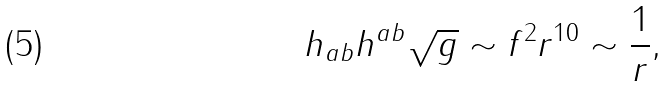Convert formula to latex. <formula><loc_0><loc_0><loc_500><loc_500>h _ { a b } h ^ { a b } \sqrt { g } \sim f ^ { 2 } r ^ { 1 0 } \sim \frac { 1 } { r } ,</formula> 